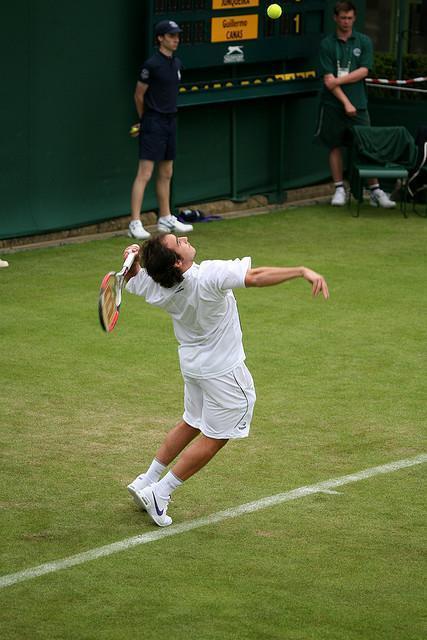How many people are there?
Give a very brief answer. 3. How many big elephants are there?
Give a very brief answer. 0. 